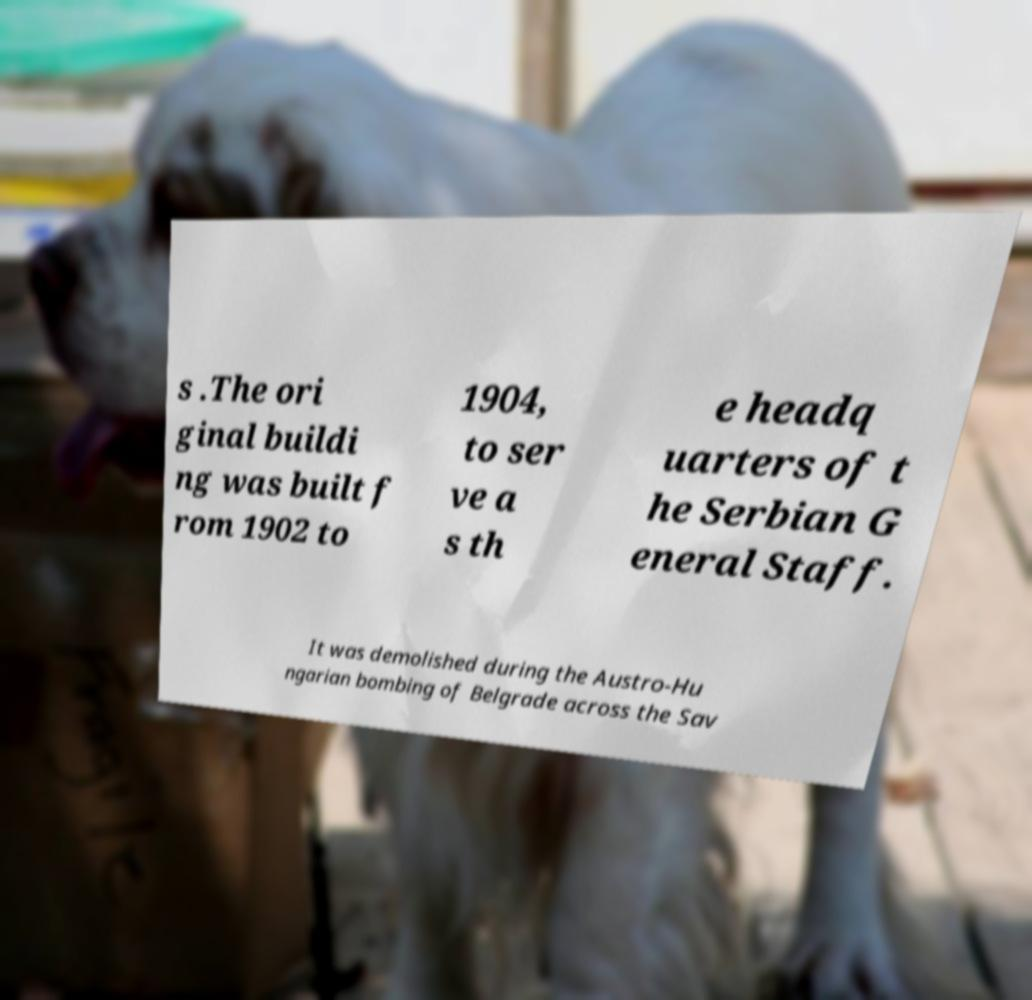Can you read and provide the text displayed in the image?This photo seems to have some interesting text. Can you extract and type it out for me? s .The ori ginal buildi ng was built f rom 1902 to 1904, to ser ve a s th e headq uarters of t he Serbian G eneral Staff. It was demolished during the Austro-Hu ngarian bombing of Belgrade across the Sav 